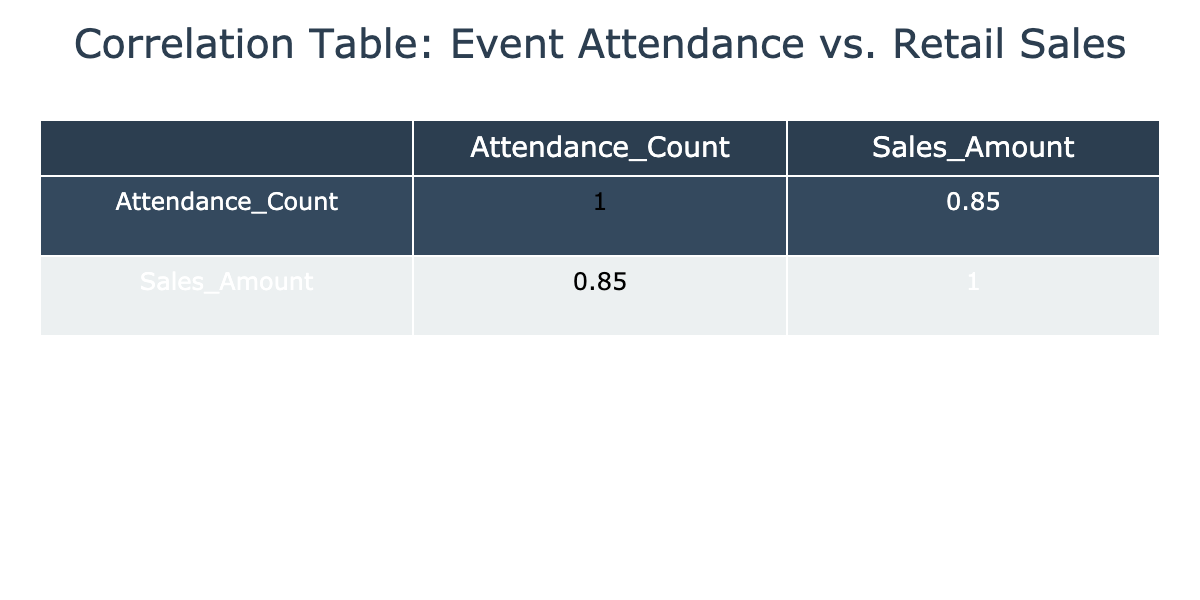What is the correlation coefficient between attendance and sales? The correlation matrix shows the correlation coefficient between 'Attendance_Count' and 'Sales_Amount' is 0.83, which indicates a strong positive correlation between event attendance and retail sales.
Answer: 0.83 Which event had the highest attendance? By looking at the 'Attendance_Count' values, the Music Festival has the highest attendance with a count of 1200.
Answer: 1200 What is the total sales amount from events that had over 500 attendees? The events with over 500 attendees are the Music Festival, Food Truck Rally, Fall Festival, and Outdoor Concert. Their sales amounts are 3200, 3000, 2800, and 4000 respectively. Summing these gives 3200 + 3000 + 2800 + 4000 = 13000.
Answer: 13000 Did the Charity Run generate more sales than the Art Walk? The sales amount for the Charity Run is 1700 and for the Art Walk is 1300. Comparing these values shows that 1700 is greater than 1300.
Answer: Yes What is the average sales amount for events with attendance counts below 500? The events with attendance counts below 500 are the Art Walk, Farmers Market, and Charity Run. Their sales amounts are 1300, 1500, and 1700, respectively. First, we sum these amounts: 1300 + 1500 + 1700 = 4500. Then, we divide by the number of events (3): 4500 / 3 = 1500.
Answer: 1500 How many events had sales amounts greater than 2000? By examining the 'Sales_Amount' column, the events with sales amounts greater than 2000 are the Music Festival, Food Truck Rally, Fall Festival, and Outdoor Concert. This gives a total of 4 events.
Answer: 4 Which event had a sales amount closest to 1600? Looking at the 'Sales_Amount', the Local Art Supply (Street Art Festival) has a sales amount of 1600 and is exactly the value we are comparing it to, while other events have amounts more distant from this figure.
Answer: Street Art Festival Calculate the difference in attendance between the Food Truck Rally and the Fall Festival. The Food Truck Rally has an attendance of 800, and the Fall Festival has an attendance of 900. The difference is calculated as 900 - 800 = 100.
Answer: 100 What was the total attendance for events that took place before October? The events before October are the Farmers Market, Music Festival, Art Walk, Food Truck Rally, and Craft Fair. Their attendance counts are 250, 1200, 300, 800, and 400, respectively. Summing these together: 250 + 1200 + 300 + 800 + 400 = 2950.
Answer: 2950 